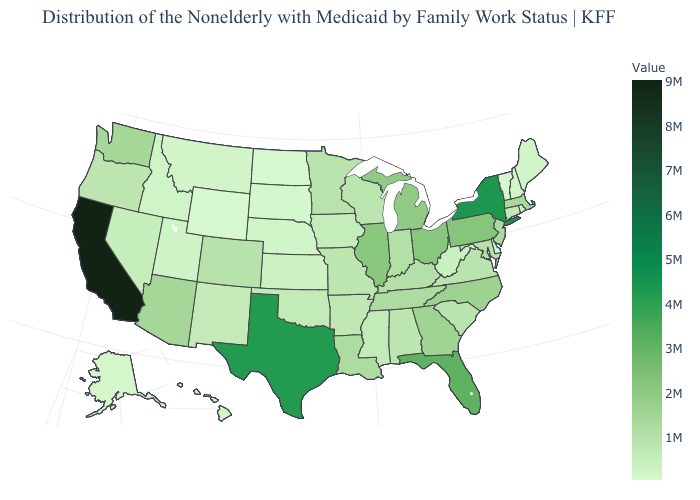Among the states that border Delaware , does Maryland have the lowest value?
Write a very short answer. Yes. Does Wisconsin have a higher value than California?
Short answer required. No. Does Tennessee have the highest value in the South?
Answer briefly. No. Among the states that border Idaho , does Wyoming have the lowest value?
Be succinct. Yes. Does Texas have the lowest value in the South?
Be succinct. No. Which states hav the highest value in the Northeast?
Keep it brief. New York. Among the states that border Delaware , does Maryland have the highest value?
Be succinct. No. Among the states that border Nebraska , does Kansas have the highest value?
Concise answer only. No. Among the states that border Idaho , does Wyoming have the lowest value?
Short answer required. Yes. 